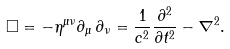<formula> <loc_0><loc_0><loc_500><loc_500>\Box = - \eta ^ { \mu \nu } \partial _ { \mu } \, \partial _ { \nu } = { \frac { 1 } { c ^ { 2 } } } { \frac { \partial ^ { 2 } } { \partial t ^ { 2 } } } - \nabla ^ { 2 } .</formula> 